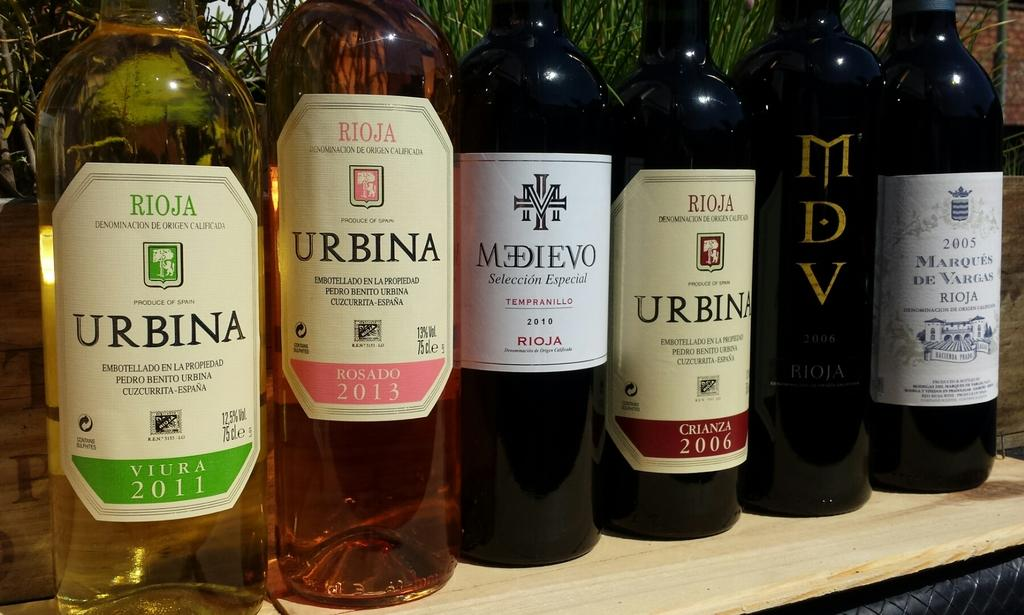<image>
Write a terse but informative summary of the picture. Bottles of wine from serveral brands such as Urbina and Medievo stand next to each other on a shelf. 